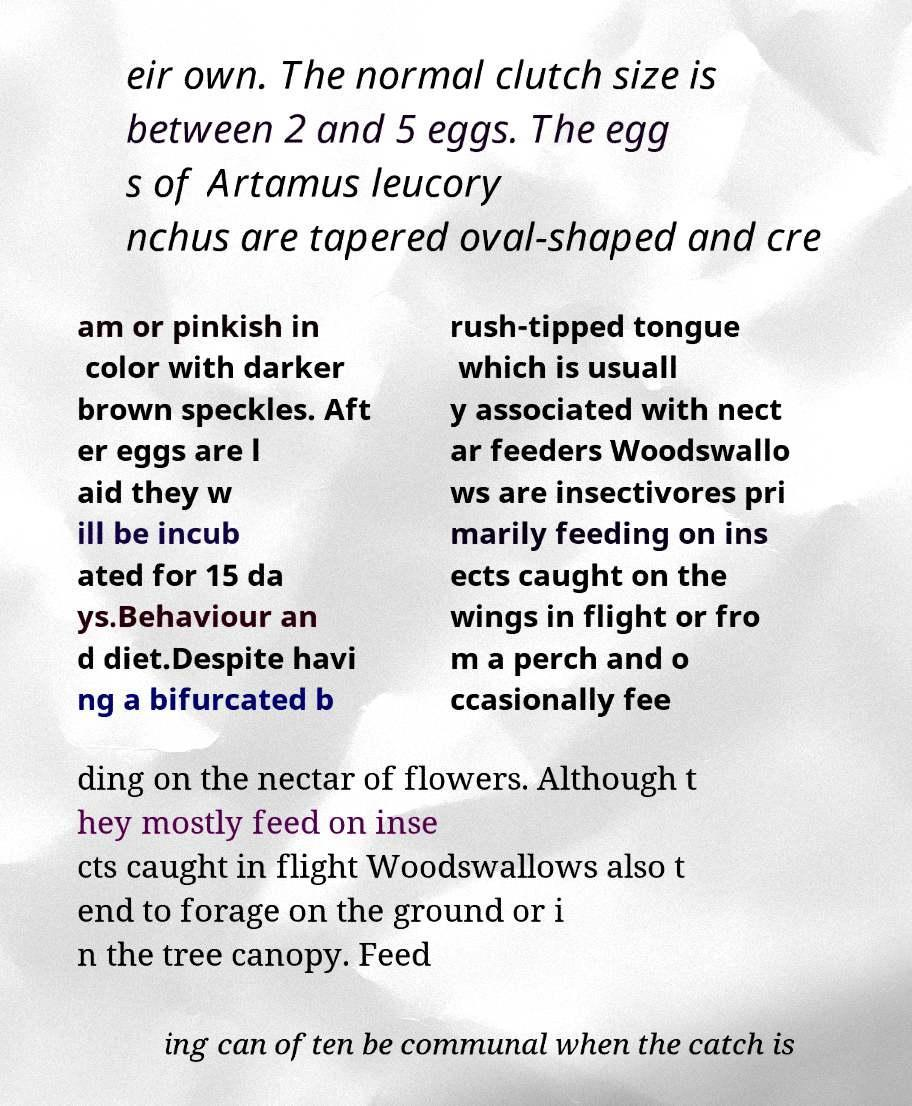What messages or text are displayed in this image? I need them in a readable, typed format. eir own. The normal clutch size is between 2 and 5 eggs. The egg s of Artamus leucory nchus are tapered oval-shaped and cre am or pinkish in color with darker brown speckles. Aft er eggs are l aid they w ill be incub ated for 15 da ys.Behaviour an d diet.Despite havi ng a bifurcated b rush-tipped tongue which is usuall y associated with nect ar feeders Woodswallo ws are insectivores pri marily feeding on ins ects caught on the wings in flight or fro m a perch and o ccasionally fee ding on the nectar of flowers. Although t hey mostly feed on inse cts caught in flight Woodswallows also t end to forage on the ground or i n the tree canopy. Feed ing can often be communal when the catch is 